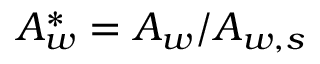<formula> <loc_0><loc_0><loc_500><loc_500>A _ { w } ^ { * } = { A _ { w } } / { A _ { w , s } }</formula> 